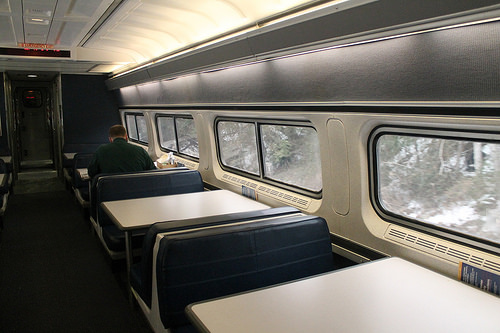<image>
Is the man in the train? Yes. The man is contained within or inside the train, showing a containment relationship. Where is the man in relation to the train? Is it in front of the train? No. The man is not in front of the train. The spatial positioning shows a different relationship between these objects. 